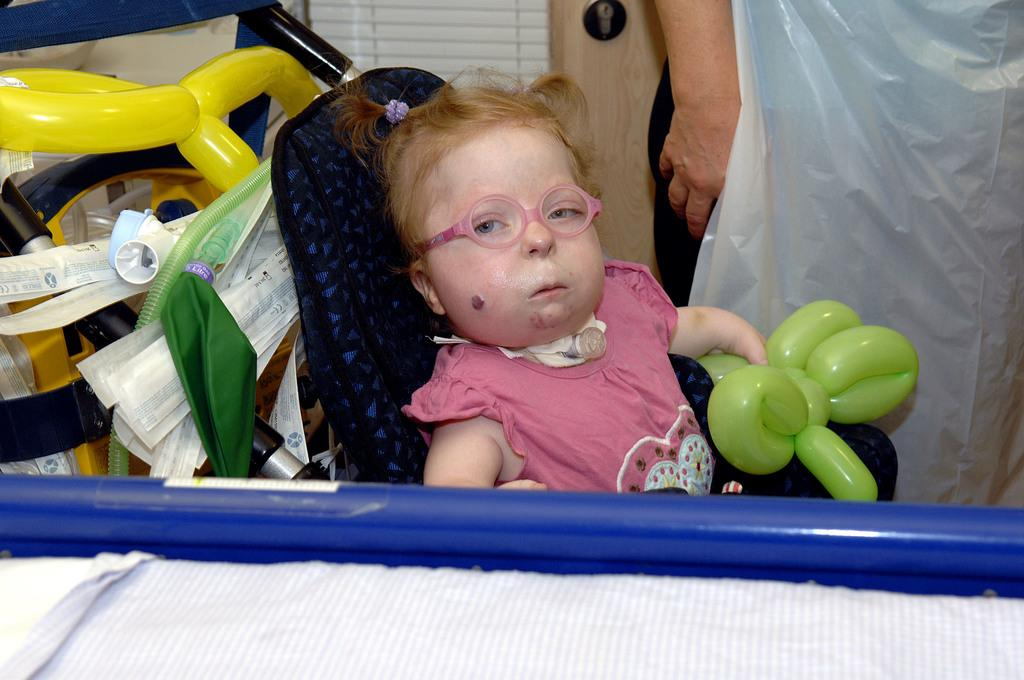Who is the main subject in the image? There is a little girl in the image. What is the girl doing in the image? The girl is sitting on a chair. What is the girl holding in her hand? The girl is holding balloons in her hand. What can be seen behind the girl? There are objects placed behind the girl. Who is present beside the girl? There is a person standing beside the girl. What type of grain is being cooked by the little girl in the image? There is no grain or cooking activity present in the image. Is the person standing beside the girl a spy? There is no indication in the image that the person standing beside the girl is a spy. 